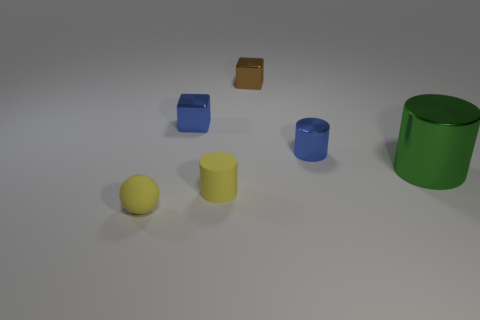What color is the tiny matte object that is on the right side of the yellow object left of the tiny shiny cube that is in front of the tiny brown object?
Offer a terse response. Yellow. What number of other objects are there of the same size as the yellow ball?
Give a very brief answer. 4. Is there any other thing that has the same shape as the big metallic object?
Ensure brevity in your answer.  Yes. What color is the small rubber thing that is the same shape as the large metallic thing?
Your response must be concise. Yellow. What is the color of the object that is made of the same material as the yellow cylinder?
Provide a succinct answer. Yellow. Are there the same number of blocks to the right of the green metal cylinder and small objects?
Ensure brevity in your answer.  No. Do the yellow matte object that is on the right side of the blue block and the blue shiny cylinder have the same size?
Offer a terse response. Yes. The shiny cylinder that is the same size as the rubber cylinder is what color?
Your answer should be very brief. Blue. Are there any yellow spheres to the left of the cylinder that is left of the blue shiny object that is in front of the tiny blue shiny block?
Provide a short and direct response. Yes. There is a cylinder that is on the left side of the brown cube; what material is it?
Your response must be concise. Rubber. 